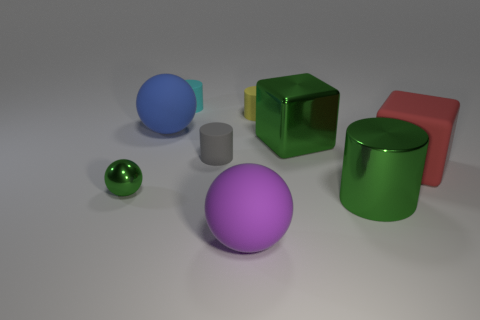Which objects in the image are spheres? There are two spheres present in the image, one in a vibrant blue color and the other in a rich purple shade. What can you tell me about the lighting in this scene? The lighting in the scene is soft and diffuse, giving the objects gentle shadows and a realistic appearance, suggesting an overhead light source slightly to the right. 